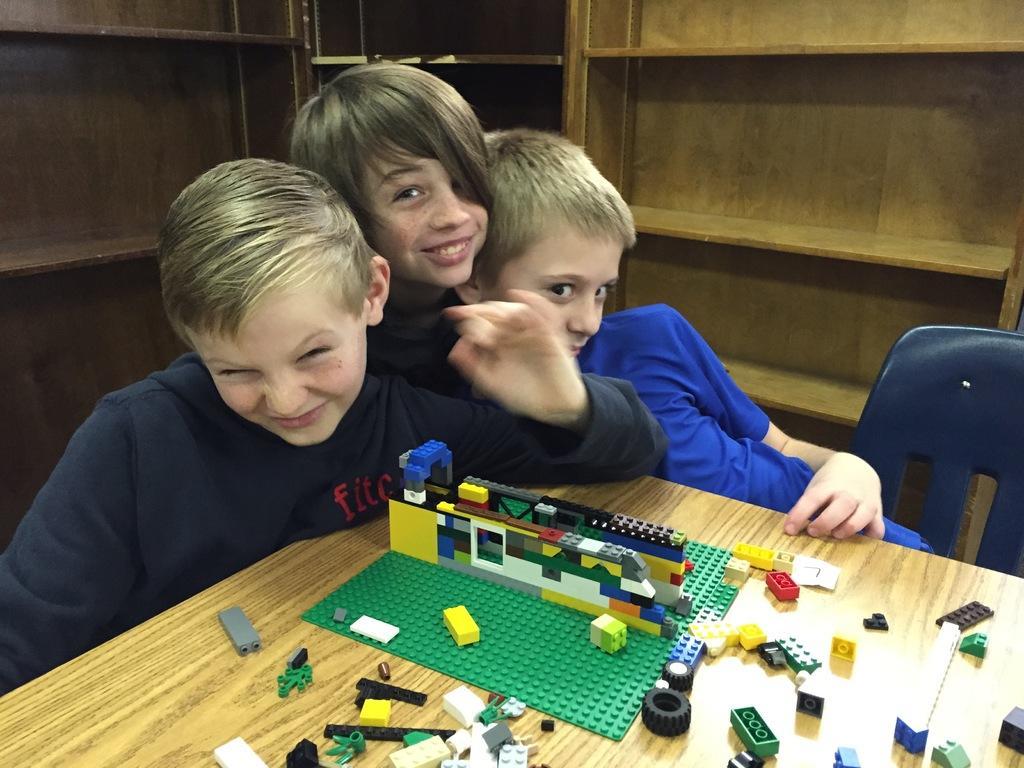Please provide a concise description of this image. In a picture there are three children which is taken in a closed room, at the right corner of the picture there is a child is wearing a blue t-shirt and the other two children are wearing dark blue t-shirts, they are sitting in front of the table on which there are lego sets are present with a matt, behind them there is a wooden shelf and at the right corner of the picture there is another wooden shelf is present. 